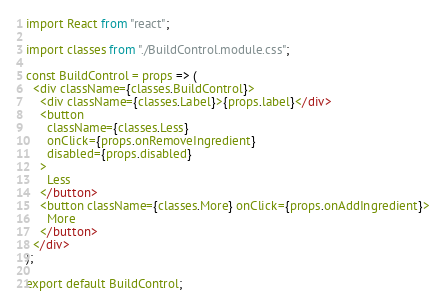Convert code to text. <code><loc_0><loc_0><loc_500><loc_500><_JavaScript_>import React from "react";

import classes from "./BuildControl.module.css";

const BuildControl = props => (
  <div className={classes.BuildControl}>
    <div className={classes.Label}>{props.label}</div>
    <button
      className={classes.Less}
      onClick={props.onRemoveIngredient}
      disabled={props.disabled}
    >
      Less
    </button>
    <button className={classes.More} onClick={props.onAddIngredient}>
      More
    </button>
  </div>
);

export default BuildControl;
</code> 